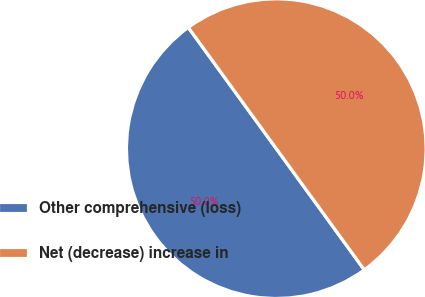Convert chart to OTSL. <chart><loc_0><loc_0><loc_500><loc_500><pie_chart><fcel>Other comprehensive (loss)<fcel>Net (decrease) increase in<nl><fcel>50.0%<fcel>50.0%<nl></chart> 